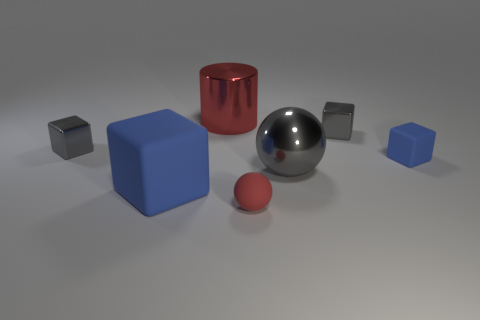What materials do the objects seem to be made of, and can you describe the texture of the large shiny sphere? The various objects in the image appear to have distinct materials. The large shiny sphere in the center looks like polished metal due to its reflective surface and specular highlights. Its texture is smooth, with no visible imperfections, reflecting its surroundings with a mirrored finish. 